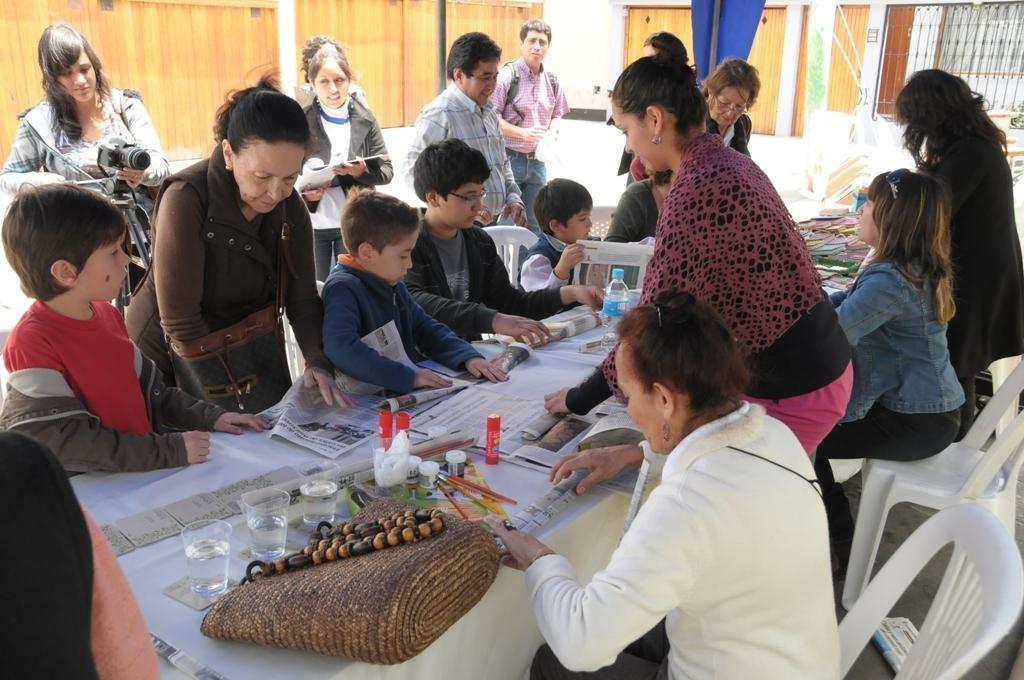Could you give a brief overview of what you see in this image? Few persons are sitting on the chairs and few persons are standing,this person holding camera. We can see papers,glasses,bottle on the table. On the background we can see wooden wall,window. 